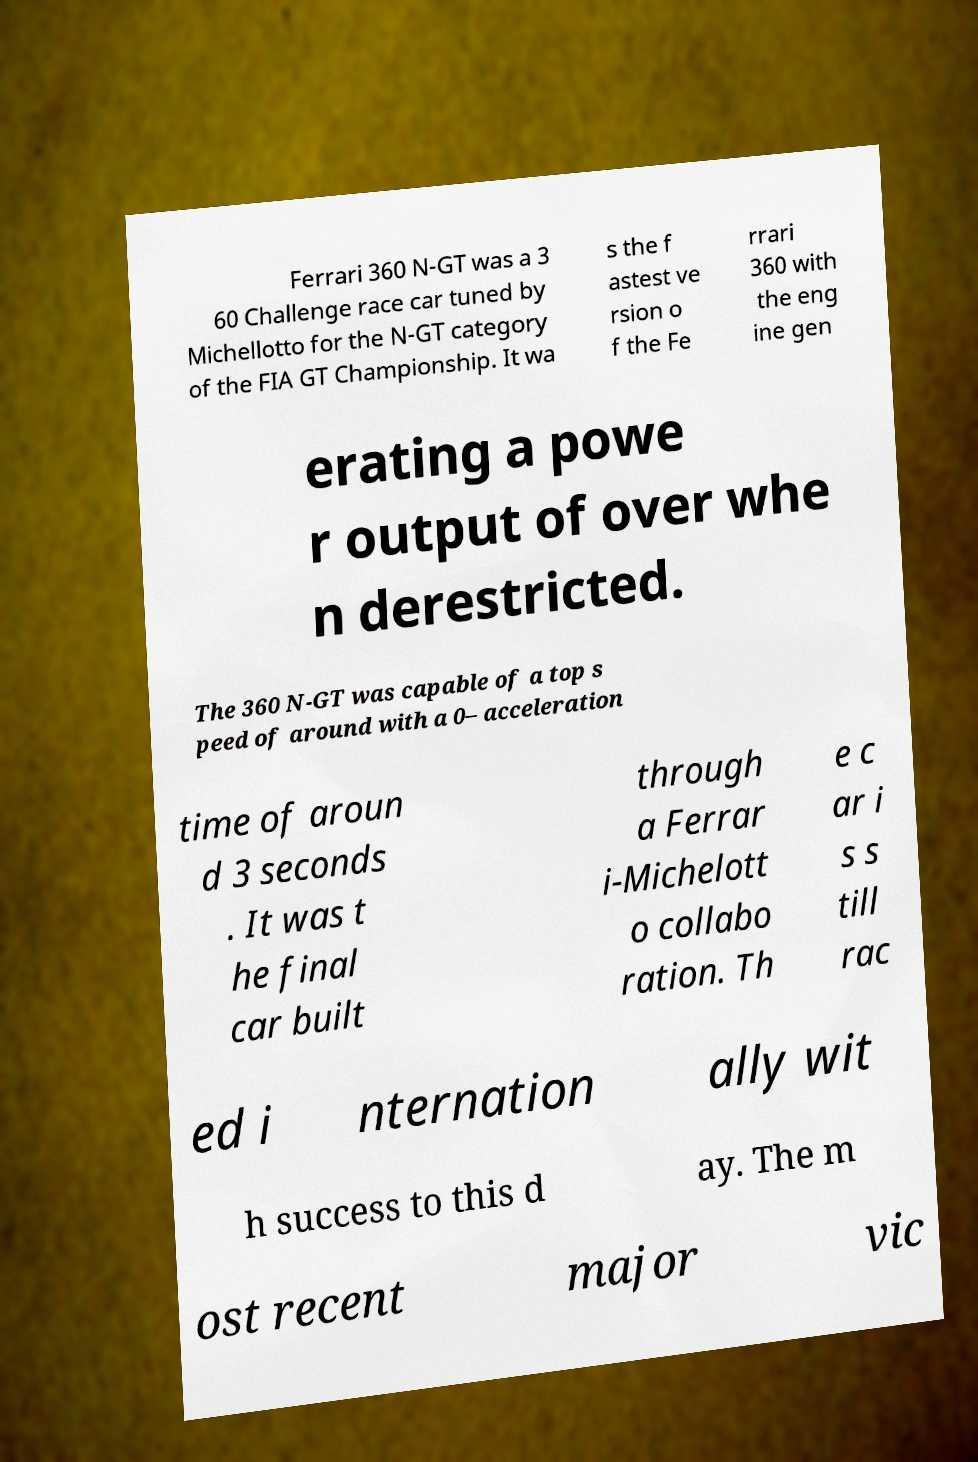I need the written content from this picture converted into text. Can you do that? Ferrari 360 N-GT was a 3 60 Challenge race car tuned by Michellotto for the N-GT category of the FIA GT Championship. It wa s the f astest ve rsion o f the Fe rrari 360 with the eng ine gen erating a powe r output of over whe n derestricted. The 360 N-GT was capable of a top s peed of around with a 0– acceleration time of aroun d 3 seconds . It was t he final car built through a Ferrar i-Michelott o collabo ration. Th e c ar i s s till rac ed i nternation ally wit h success to this d ay. The m ost recent major vic 